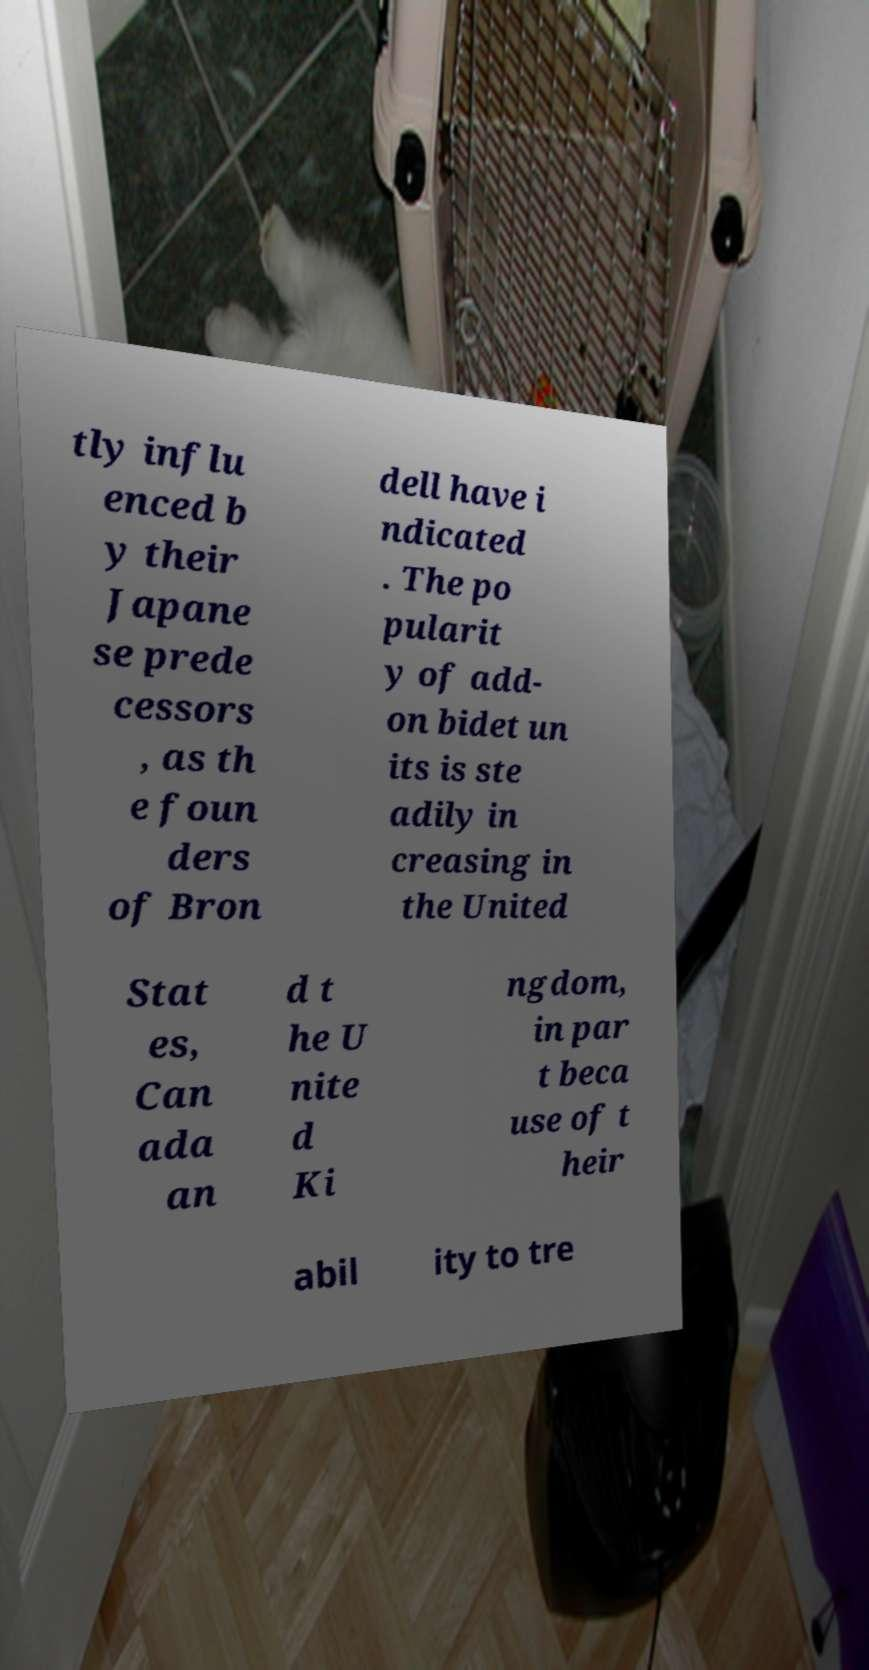There's text embedded in this image that I need extracted. Can you transcribe it verbatim? tly influ enced b y their Japane se prede cessors , as th e foun ders of Bron dell have i ndicated . The po pularit y of add- on bidet un its is ste adily in creasing in the United Stat es, Can ada an d t he U nite d Ki ngdom, in par t beca use of t heir abil ity to tre 